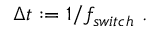Convert formula to latex. <formula><loc_0><loc_0><loc_500><loc_500>\begin{array} { r } { \Delta t \colon = 1 / f _ { s w i t c h } \ . } \end{array}</formula> 